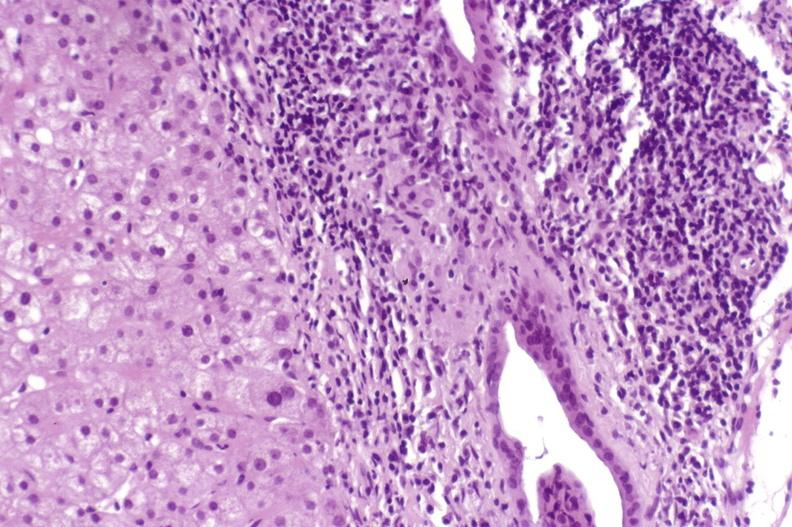s hepatobiliary present?
Answer the question using a single word or phrase. Yes 